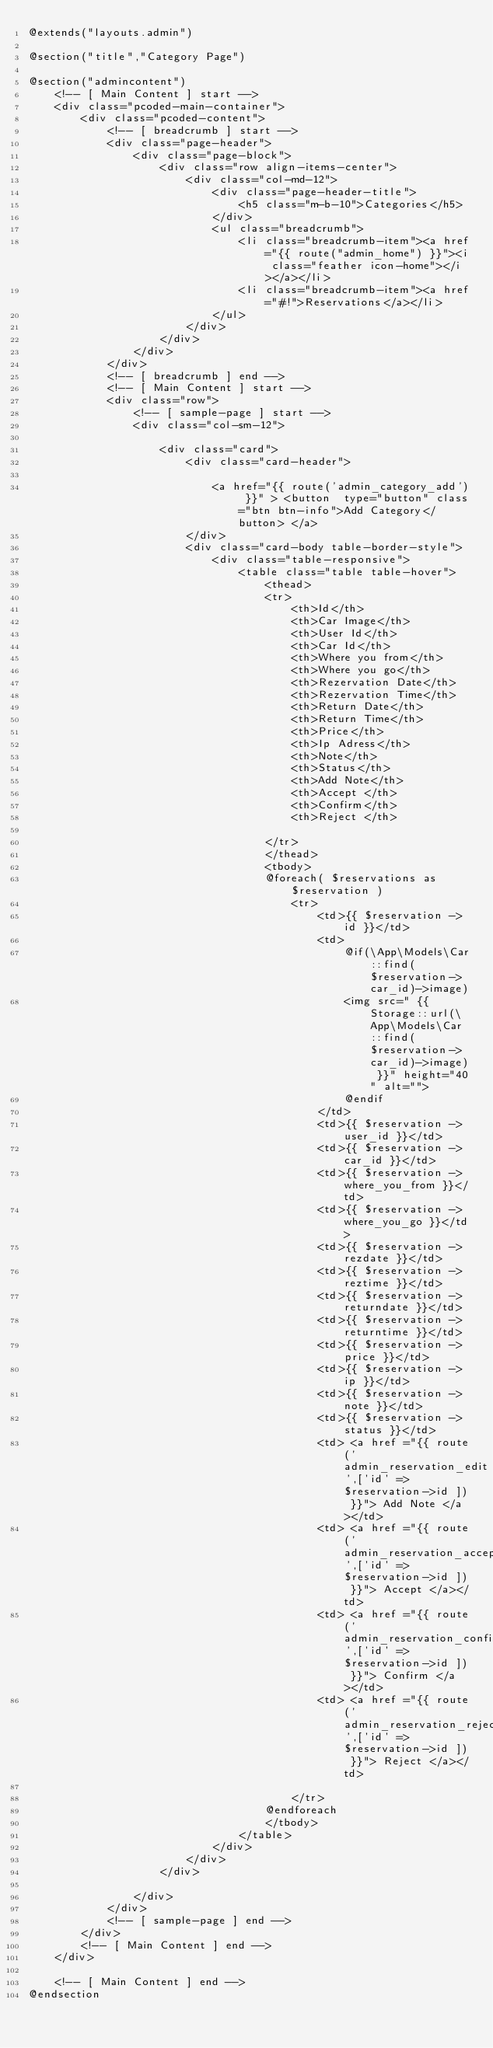Convert code to text. <code><loc_0><loc_0><loc_500><loc_500><_PHP_>@extends("layouts.admin")

@section("title","Category Page")

@section("admincontent")
    <!-- [ Main Content ] start -->
    <div class="pcoded-main-container">
        <div class="pcoded-content">
            <!-- [ breadcrumb ] start -->
            <div class="page-header">
                <div class="page-block">
                    <div class="row align-items-center">
                        <div class="col-md-12">
                            <div class="page-header-title">
                                <h5 class="m-b-10">Categories</h5>
                            </div>
                            <ul class="breadcrumb">
                                <li class="breadcrumb-item"><a href="{{ route("admin_home") }}"><i class="feather icon-home"></i></a></li>
                                <li class="breadcrumb-item"><a href="#!">Reservations</a></li>
                            </ul>
                        </div>
                    </div>
                </div>
            </div>
            <!-- [ breadcrumb ] end -->
            <!-- [ Main Content ] start -->
            <div class="row">
                <!-- [ sample-page ] start -->
                <div class="col-sm-12">

                    <div class="card">
                        <div class="card-header">

                            <a href="{{ route('admin_category_add') }}" > <button  type="button" class="btn btn-info">Add Category</button> </a>
                        </div>
                        <div class="card-body table-border-style">
                            <div class="table-responsive">
                                <table class="table table-hover">
                                    <thead>
                                    <tr>
                                        <th>Id</th>
                                        <th>Car Image</th>
                                        <th>User Id</th>
                                        <th>Car Id</th>
                                        <th>Where you from</th>
                                        <th>Where you go</th>
                                        <th>Rezervation Date</th>
                                        <th>Rezervation Time</th>
                                        <th>Return Date</th>
                                        <th>Return Time</th>
                                        <th>Price</th>
                                        <th>Ip Adress</th>
                                        <th>Note</th>
                                        <th>Status</th>
                                        <th>Add Note</th>
                                        <th>Accept </th>
                                        <th>Confirm</th>
                                        <th>Reject </th>

                                    </tr>
                                    </thead>
                                    <tbody>
                                    @foreach( $reservations as $reservation )
                                        <tr>
                                            <td>{{ $reservation -> id }}</td>
                                            <td>
                                                @if(\App\Models\Car::find($reservation->car_id)->image)
                                                <img src=" {{ Storage::url(\App\Models\Car::find($reservation->car_id)->image) }}" height="40" alt="">
                                                @endif
                                            </td>
                                            <td>{{ $reservation -> user_id }}</td>
                                            <td>{{ $reservation -> car_id }}</td>
                                            <td>{{ $reservation -> where_you_from }}</td>
                                            <td>{{ $reservation -> where_you_go }}</td>
                                            <td>{{ $reservation -> rezdate }}</td>
                                            <td>{{ $reservation -> reztime }}</td>
                                            <td>{{ $reservation -> returndate }}</td>
                                            <td>{{ $reservation -> returntime }}</td>
                                            <td>{{ $reservation -> price }}</td>
                                            <td>{{ $reservation -> ip }}</td>
                                            <td>{{ $reservation -> note }}</td>
                                            <td>{{ $reservation -> status }}</td>
                                            <td> <a href ="{{ route('admin_reservation_edit',['id' => $reservation->id ]) }}"> Add Note </a></td>
                                            <td> <a href ="{{ route('admin_reservation_accept',['id' => $reservation->id ]) }}"> Accept </a></td>
                                            <td> <a href ="{{ route('admin_reservation_confirm',['id' => $reservation->id ]) }}"> Confirm </a></td>
                                            <td> <a href ="{{ route('admin_reservation_reject',['id' => $reservation->id ]) }}"> Reject </a></td>

                                        </tr>
                                    @endforeach
                                    </tbody>
                                </table>
                            </div>
                        </div>
                    </div>

                </div>
            </div>
            <!-- [ sample-page ] end -->
        </div>
        <!-- [ Main Content ] end -->
    </div>

    <!-- [ Main Content ] end -->
@endsection

</code> 